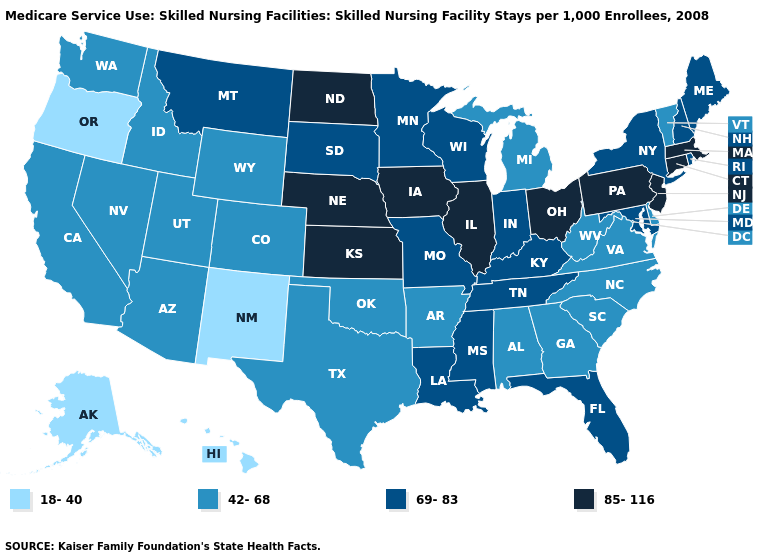Does Florida have the highest value in the South?
Keep it brief. Yes. Does the first symbol in the legend represent the smallest category?
Quick response, please. Yes. What is the value of Delaware?
Answer briefly. 42-68. What is the value of Connecticut?
Keep it brief. 85-116. Name the states that have a value in the range 69-83?
Answer briefly. Florida, Indiana, Kentucky, Louisiana, Maine, Maryland, Minnesota, Mississippi, Missouri, Montana, New Hampshire, New York, Rhode Island, South Dakota, Tennessee, Wisconsin. Name the states that have a value in the range 69-83?
Quick response, please. Florida, Indiana, Kentucky, Louisiana, Maine, Maryland, Minnesota, Mississippi, Missouri, Montana, New Hampshire, New York, Rhode Island, South Dakota, Tennessee, Wisconsin. Among the states that border Connecticut , which have the highest value?
Short answer required. Massachusetts. Which states have the lowest value in the Northeast?
Quick response, please. Vermont. What is the highest value in the MidWest ?
Be succinct. 85-116. Which states have the lowest value in the USA?
Concise answer only. Alaska, Hawaii, New Mexico, Oregon. Name the states that have a value in the range 18-40?
Write a very short answer. Alaska, Hawaii, New Mexico, Oregon. Name the states that have a value in the range 42-68?
Concise answer only. Alabama, Arizona, Arkansas, California, Colorado, Delaware, Georgia, Idaho, Michigan, Nevada, North Carolina, Oklahoma, South Carolina, Texas, Utah, Vermont, Virginia, Washington, West Virginia, Wyoming. What is the value of Missouri?
Short answer required. 69-83. Among the states that border Colorado , which have the highest value?
Answer briefly. Kansas, Nebraska. Among the states that border South Carolina , which have the highest value?
Write a very short answer. Georgia, North Carolina. 